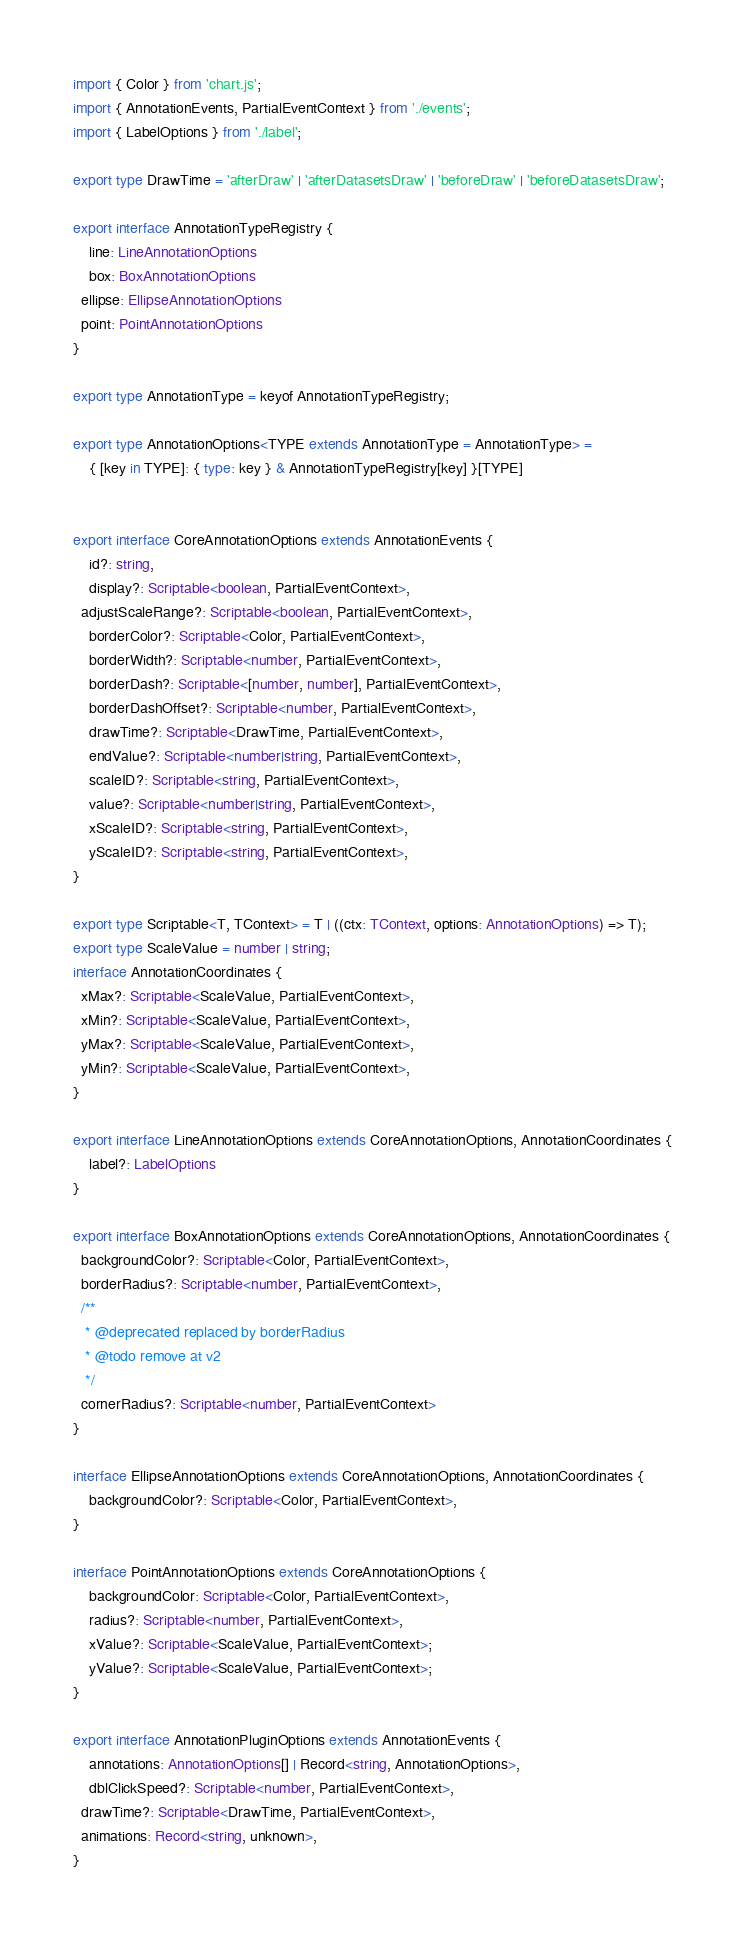<code> <loc_0><loc_0><loc_500><loc_500><_TypeScript_>import { Color } from 'chart.js';
import { AnnotationEvents, PartialEventContext } from './events';
import { LabelOptions } from './label';

export type DrawTime = 'afterDraw' | 'afterDatasetsDraw' | 'beforeDraw' | 'beforeDatasetsDraw';

export interface AnnotationTypeRegistry {
	line: LineAnnotationOptions
	box: BoxAnnotationOptions
  ellipse: EllipseAnnotationOptions
  point: PointAnnotationOptions
}

export type AnnotationType = keyof AnnotationTypeRegistry;

export type AnnotationOptions<TYPE extends AnnotationType = AnnotationType> =
	{ [key in TYPE]: { type: key } & AnnotationTypeRegistry[key] }[TYPE]


export interface CoreAnnotationOptions extends AnnotationEvents {
	id?: string,
	display?: Scriptable<boolean, PartialEventContext>,
  adjustScaleRange?: Scriptable<boolean, PartialEventContext>,
	borderColor?: Scriptable<Color, PartialEventContext>,
	borderWidth?: Scriptable<number, PartialEventContext>,
	borderDash?: Scriptable<[number, number], PartialEventContext>,
	borderDashOffset?: Scriptable<number, PartialEventContext>,
	drawTime?: Scriptable<DrawTime, PartialEventContext>,
	endValue?: Scriptable<number|string, PartialEventContext>,
	scaleID?: Scriptable<string, PartialEventContext>,
	value?: Scriptable<number|string, PartialEventContext>,
	xScaleID?: Scriptable<string, PartialEventContext>,
	yScaleID?: Scriptable<string, PartialEventContext>,
}

export type Scriptable<T, TContext> = T | ((ctx: TContext, options: AnnotationOptions) => T);
export type ScaleValue = number | string;
interface AnnotationCoordinates {
  xMax?: Scriptable<ScaleValue, PartialEventContext>,
  xMin?: Scriptable<ScaleValue, PartialEventContext>,
  yMax?: Scriptable<ScaleValue, PartialEventContext>,
  yMin?: Scriptable<ScaleValue, PartialEventContext>,
}

export interface LineAnnotationOptions extends CoreAnnotationOptions, AnnotationCoordinates {
	label?: LabelOptions
}

export interface BoxAnnotationOptions extends CoreAnnotationOptions, AnnotationCoordinates {
  backgroundColor?: Scriptable<Color, PartialEventContext>,
  borderRadius?: Scriptable<number, PartialEventContext>,
  /**
   * @deprecated replaced by borderRadius
   * @todo remove at v2
   */
  cornerRadius?: Scriptable<number, PartialEventContext>
}

interface EllipseAnnotationOptions extends CoreAnnotationOptions, AnnotationCoordinates {
	backgroundColor?: Scriptable<Color, PartialEventContext>,
}

interface PointAnnotationOptions extends CoreAnnotationOptions {
	backgroundColor: Scriptable<Color, PartialEventContext>,
	radius?: Scriptable<number, PartialEventContext>,
	xValue?: Scriptable<ScaleValue, PartialEventContext>;
	yValue?: Scriptable<ScaleValue, PartialEventContext>;
}

export interface AnnotationPluginOptions extends AnnotationEvents {
	annotations: AnnotationOptions[] | Record<string, AnnotationOptions>,
	dblClickSpeed?: Scriptable<number, PartialEventContext>,
  drawTime?: Scriptable<DrawTime, PartialEventContext>,
  animations: Record<string, unknown>,
}
</code> 